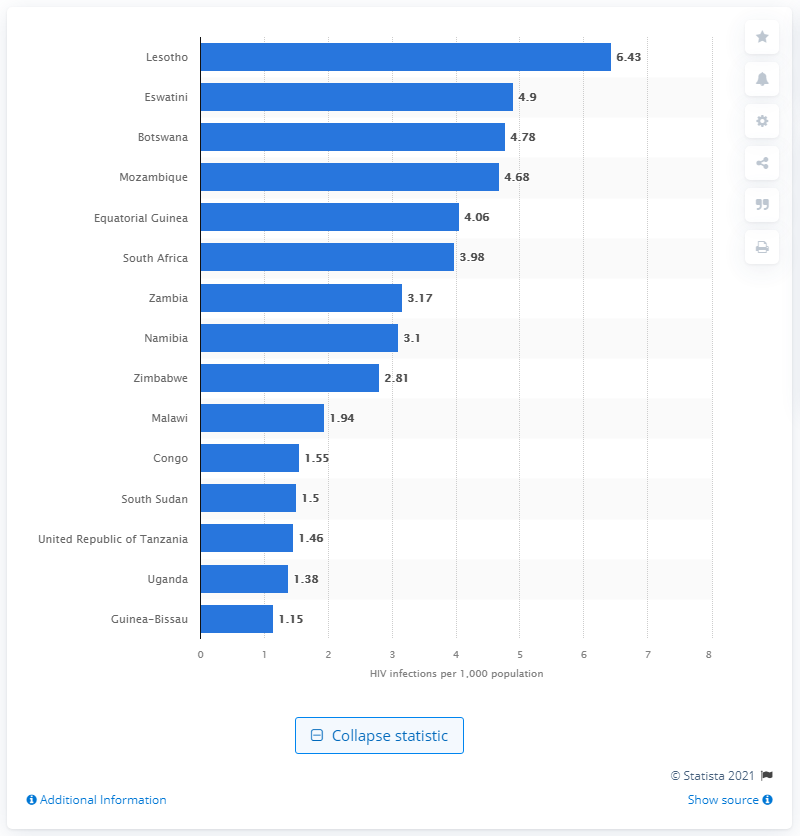Specify some key components in this picture. In South Africa, an estimated 3.98 new HIV infections occurred per 1,000 inhabitants in 